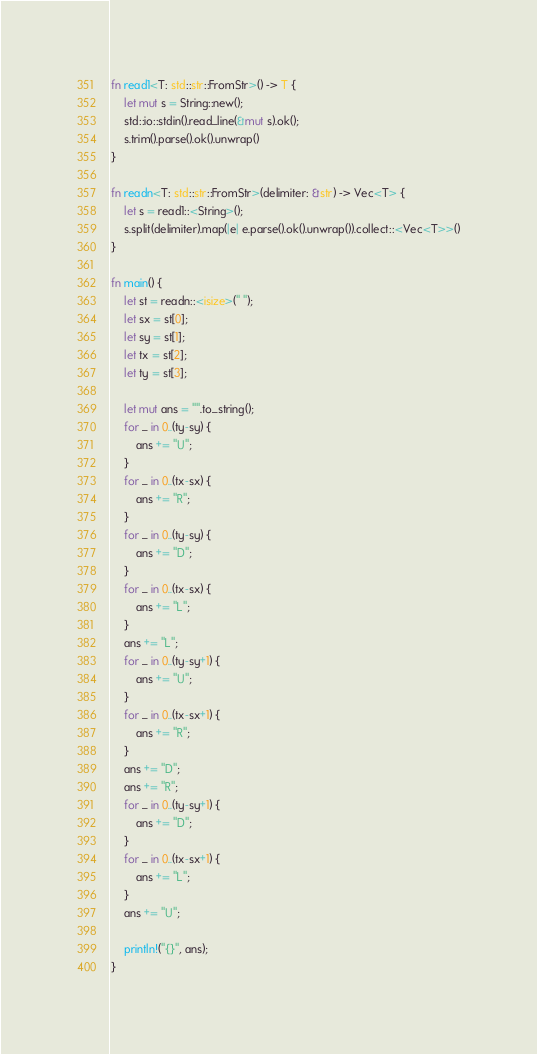Convert code to text. <code><loc_0><loc_0><loc_500><loc_500><_Rust_>fn read1<T: std::str::FromStr>() -> T {
    let mut s = String::new();
    std::io::stdin().read_line(&mut s).ok();
    s.trim().parse().ok().unwrap()
}

fn readn<T: std::str::FromStr>(delimiter: &str) -> Vec<T> {
    let s = read1::<String>();
    s.split(delimiter).map(|e| e.parse().ok().unwrap()).collect::<Vec<T>>()
}

fn main() {
    let st = readn::<isize>(" ");
    let sx = st[0];
    let sy = st[1];
    let tx = st[2];
    let ty = st[3];

    let mut ans = "".to_string();
    for _ in 0..(ty-sy) {
        ans += "U";
    }
    for _ in 0..(tx-sx) {
        ans += "R";
    }
    for _ in 0..(ty-sy) {
        ans += "D";
    }
    for _ in 0..(tx-sx) {
        ans += "L";
    }
    ans += "L";
    for _ in 0..(ty-sy+1) {
        ans += "U";
    }
    for _ in 0..(tx-sx+1) {
        ans += "R";
    }
    ans += "D";
    ans += "R";
    for _ in 0..(ty-sy+1) {
        ans += "D";
    }
    for _ in 0..(tx-sx+1) {
        ans += "L";
    }
    ans += "U";

    println!("{}", ans);
}</code> 